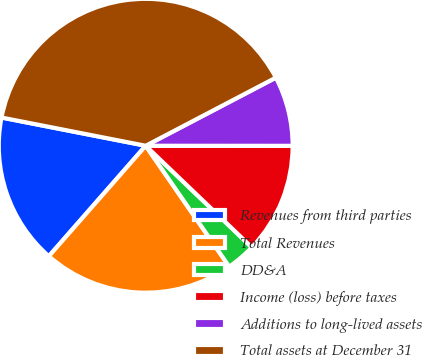Convert chart to OTSL. <chart><loc_0><loc_0><loc_500><loc_500><pie_chart><fcel>Revenues from third parties<fcel>Total Revenues<fcel>DD&A<fcel>Income (loss) before taxes<fcel>Additions to long-lived assets<fcel>Total assets at December 31<nl><fcel>16.62%<fcel>21.08%<fcel>3.22%<fcel>12.15%<fcel>7.68%<fcel>39.25%<nl></chart> 